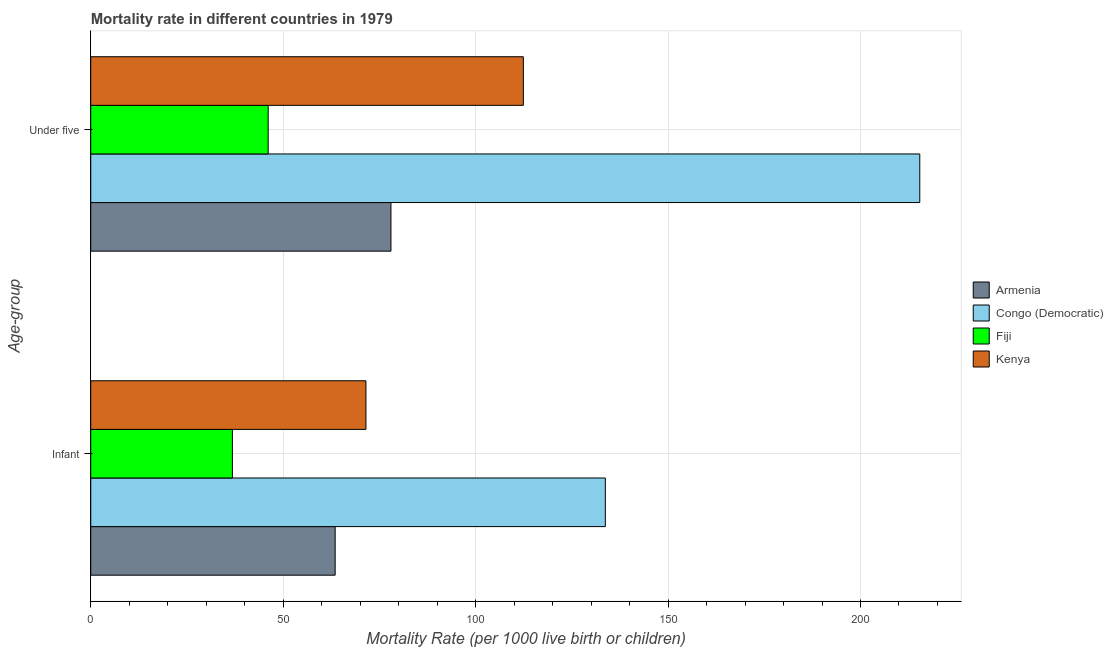How many groups of bars are there?
Make the answer very short. 2. What is the label of the 2nd group of bars from the top?
Keep it short and to the point. Infant. Across all countries, what is the maximum under-5 mortality rate?
Your response must be concise. 215.4. Across all countries, what is the minimum infant mortality rate?
Keep it short and to the point. 36.8. In which country was the under-5 mortality rate maximum?
Your response must be concise. Congo (Democratic). In which country was the infant mortality rate minimum?
Provide a succinct answer. Fiji. What is the total under-5 mortality rate in the graph?
Offer a very short reply. 451.9. What is the difference between the under-5 mortality rate in Armenia and that in Fiji?
Provide a succinct answer. 31.9. What is the difference between the infant mortality rate in Fiji and the under-5 mortality rate in Congo (Democratic)?
Offer a very short reply. -178.6. What is the average infant mortality rate per country?
Your answer should be very brief. 76.38. What is the difference between the under-5 mortality rate and infant mortality rate in Kenya?
Provide a succinct answer. 40.9. What is the ratio of the under-5 mortality rate in Kenya to that in Armenia?
Provide a short and direct response. 1.44. Is the infant mortality rate in Congo (Democratic) less than that in Kenya?
Provide a succinct answer. No. What does the 3rd bar from the top in Infant represents?
Your answer should be very brief. Congo (Democratic). What does the 4th bar from the bottom in Under five represents?
Ensure brevity in your answer.  Kenya. How many bars are there?
Your answer should be very brief. 8. How many countries are there in the graph?
Give a very brief answer. 4. Does the graph contain any zero values?
Your answer should be very brief. No. Where does the legend appear in the graph?
Offer a terse response. Center right. How many legend labels are there?
Make the answer very short. 4. How are the legend labels stacked?
Offer a very short reply. Vertical. What is the title of the graph?
Your answer should be compact. Mortality rate in different countries in 1979. Does "San Marino" appear as one of the legend labels in the graph?
Ensure brevity in your answer.  No. What is the label or title of the X-axis?
Give a very brief answer. Mortality Rate (per 1000 live birth or children). What is the label or title of the Y-axis?
Your answer should be very brief. Age-group. What is the Mortality Rate (per 1000 live birth or children) of Armenia in Infant?
Provide a succinct answer. 63.5. What is the Mortality Rate (per 1000 live birth or children) in Congo (Democratic) in Infant?
Ensure brevity in your answer.  133.7. What is the Mortality Rate (per 1000 live birth or children) of Fiji in Infant?
Your response must be concise. 36.8. What is the Mortality Rate (per 1000 live birth or children) in Kenya in Infant?
Your answer should be compact. 71.5. What is the Mortality Rate (per 1000 live birth or children) in Congo (Democratic) in Under five?
Provide a succinct answer. 215.4. What is the Mortality Rate (per 1000 live birth or children) of Fiji in Under five?
Provide a succinct answer. 46.1. What is the Mortality Rate (per 1000 live birth or children) of Kenya in Under five?
Give a very brief answer. 112.4. Across all Age-group, what is the maximum Mortality Rate (per 1000 live birth or children) of Armenia?
Make the answer very short. 78. Across all Age-group, what is the maximum Mortality Rate (per 1000 live birth or children) of Congo (Democratic)?
Offer a very short reply. 215.4. Across all Age-group, what is the maximum Mortality Rate (per 1000 live birth or children) of Fiji?
Your response must be concise. 46.1. Across all Age-group, what is the maximum Mortality Rate (per 1000 live birth or children) of Kenya?
Provide a succinct answer. 112.4. Across all Age-group, what is the minimum Mortality Rate (per 1000 live birth or children) of Armenia?
Your answer should be very brief. 63.5. Across all Age-group, what is the minimum Mortality Rate (per 1000 live birth or children) of Congo (Democratic)?
Make the answer very short. 133.7. Across all Age-group, what is the minimum Mortality Rate (per 1000 live birth or children) in Fiji?
Make the answer very short. 36.8. Across all Age-group, what is the minimum Mortality Rate (per 1000 live birth or children) of Kenya?
Ensure brevity in your answer.  71.5. What is the total Mortality Rate (per 1000 live birth or children) in Armenia in the graph?
Provide a succinct answer. 141.5. What is the total Mortality Rate (per 1000 live birth or children) of Congo (Democratic) in the graph?
Make the answer very short. 349.1. What is the total Mortality Rate (per 1000 live birth or children) in Fiji in the graph?
Make the answer very short. 82.9. What is the total Mortality Rate (per 1000 live birth or children) of Kenya in the graph?
Your answer should be compact. 183.9. What is the difference between the Mortality Rate (per 1000 live birth or children) of Armenia in Infant and that in Under five?
Your answer should be compact. -14.5. What is the difference between the Mortality Rate (per 1000 live birth or children) in Congo (Democratic) in Infant and that in Under five?
Offer a very short reply. -81.7. What is the difference between the Mortality Rate (per 1000 live birth or children) in Kenya in Infant and that in Under five?
Offer a very short reply. -40.9. What is the difference between the Mortality Rate (per 1000 live birth or children) in Armenia in Infant and the Mortality Rate (per 1000 live birth or children) in Congo (Democratic) in Under five?
Your answer should be very brief. -151.9. What is the difference between the Mortality Rate (per 1000 live birth or children) in Armenia in Infant and the Mortality Rate (per 1000 live birth or children) in Kenya in Under five?
Ensure brevity in your answer.  -48.9. What is the difference between the Mortality Rate (per 1000 live birth or children) in Congo (Democratic) in Infant and the Mortality Rate (per 1000 live birth or children) in Fiji in Under five?
Keep it short and to the point. 87.6. What is the difference between the Mortality Rate (per 1000 live birth or children) of Congo (Democratic) in Infant and the Mortality Rate (per 1000 live birth or children) of Kenya in Under five?
Make the answer very short. 21.3. What is the difference between the Mortality Rate (per 1000 live birth or children) in Fiji in Infant and the Mortality Rate (per 1000 live birth or children) in Kenya in Under five?
Offer a terse response. -75.6. What is the average Mortality Rate (per 1000 live birth or children) in Armenia per Age-group?
Ensure brevity in your answer.  70.75. What is the average Mortality Rate (per 1000 live birth or children) in Congo (Democratic) per Age-group?
Give a very brief answer. 174.55. What is the average Mortality Rate (per 1000 live birth or children) of Fiji per Age-group?
Provide a succinct answer. 41.45. What is the average Mortality Rate (per 1000 live birth or children) of Kenya per Age-group?
Ensure brevity in your answer.  91.95. What is the difference between the Mortality Rate (per 1000 live birth or children) of Armenia and Mortality Rate (per 1000 live birth or children) of Congo (Democratic) in Infant?
Keep it short and to the point. -70.2. What is the difference between the Mortality Rate (per 1000 live birth or children) of Armenia and Mortality Rate (per 1000 live birth or children) of Fiji in Infant?
Make the answer very short. 26.7. What is the difference between the Mortality Rate (per 1000 live birth or children) of Congo (Democratic) and Mortality Rate (per 1000 live birth or children) of Fiji in Infant?
Provide a succinct answer. 96.9. What is the difference between the Mortality Rate (per 1000 live birth or children) in Congo (Democratic) and Mortality Rate (per 1000 live birth or children) in Kenya in Infant?
Offer a terse response. 62.2. What is the difference between the Mortality Rate (per 1000 live birth or children) of Fiji and Mortality Rate (per 1000 live birth or children) of Kenya in Infant?
Offer a terse response. -34.7. What is the difference between the Mortality Rate (per 1000 live birth or children) of Armenia and Mortality Rate (per 1000 live birth or children) of Congo (Democratic) in Under five?
Keep it short and to the point. -137.4. What is the difference between the Mortality Rate (per 1000 live birth or children) of Armenia and Mortality Rate (per 1000 live birth or children) of Fiji in Under five?
Offer a very short reply. 31.9. What is the difference between the Mortality Rate (per 1000 live birth or children) in Armenia and Mortality Rate (per 1000 live birth or children) in Kenya in Under five?
Ensure brevity in your answer.  -34.4. What is the difference between the Mortality Rate (per 1000 live birth or children) in Congo (Democratic) and Mortality Rate (per 1000 live birth or children) in Fiji in Under five?
Your response must be concise. 169.3. What is the difference between the Mortality Rate (per 1000 live birth or children) of Congo (Democratic) and Mortality Rate (per 1000 live birth or children) of Kenya in Under five?
Make the answer very short. 103. What is the difference between the Mortality Rate (per 1000 live birth or children) in Fiji and Mortality Rate (per 1000 live birth or children) in Kenya in Under five?
Your answer should be very brief. -66.3. What is the ratio of the Mortality Rate (per 1000 live birth or children) in Armenia in Infant to that in Under five?
Your answer should be compact. 0.81. What is the ratio of the Mortality Rate (per 1000 live birth or children) in Congo (Democratic) in Infant to that in Under five?
Offer a terse response. 0.62. What is the ratio of the Mortality Rate (per 1000 live birth or children) in Fiji in Infant to that in Under five?
Your response must be concise. 0.8. What is the ratio of the Mortality Rate (per 1000 live birth or children) of Kenya in Infant to that in Under five?
Your answer should be compact. 0.64. What is the difference between the highest and the second highest Mortality Rate (per 1000 live birth or children) of Armenia?
Your response must be concise. 14.5. What is the difference between the highest and the second highest Mortality Rate (per 1000 live birth or children) of Congo (Democratic)?
Your response must be concise. 81.7. What is the difference between the highest and the second highest Mortality Rate (per 1000 live birth or children) of Fiji?
Make the answer very short. 9.3. What is the difference between the highest and the second highest Mortality Rate (per 1000 live birth or children) of Kenya?
Keep it short and to the point. 40.9. What is the difference between the highest and the lowest Mortality Rate (per 1000 live birth or children) in Congo (Democratic)?
Offer a terse response. 81.7. What is the difference between the highest and the lowest Mortality Rate (per 1000 live birth or children) in Fiji?
Ensure brevity in your answer.  9.3. What is the difference between the highest and the lowest Mortality Rate (per 1000 live birth or children) of Kenya?
Give a very brief answer. 40.9. 